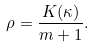<formula> <loc_0><loc_0><loc_500><loc_500>\rho = \frac { K ( \kappa ) } { m + 1 } .</formula> 